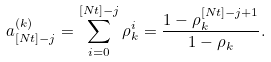<formula> <loc_0><loc_0><loc_500><loc_500>a ^ { ( k ) } _ { [ N t ] - j } = \sum _ { i = 0 } ^ { [ N t ] - j } \rho _ { k } ^ { i } = \frac { 1 - \rho _ { k } ^ { [ N t ] - j + 1 } } { 1 - \rho _ { k } } .</formula> 